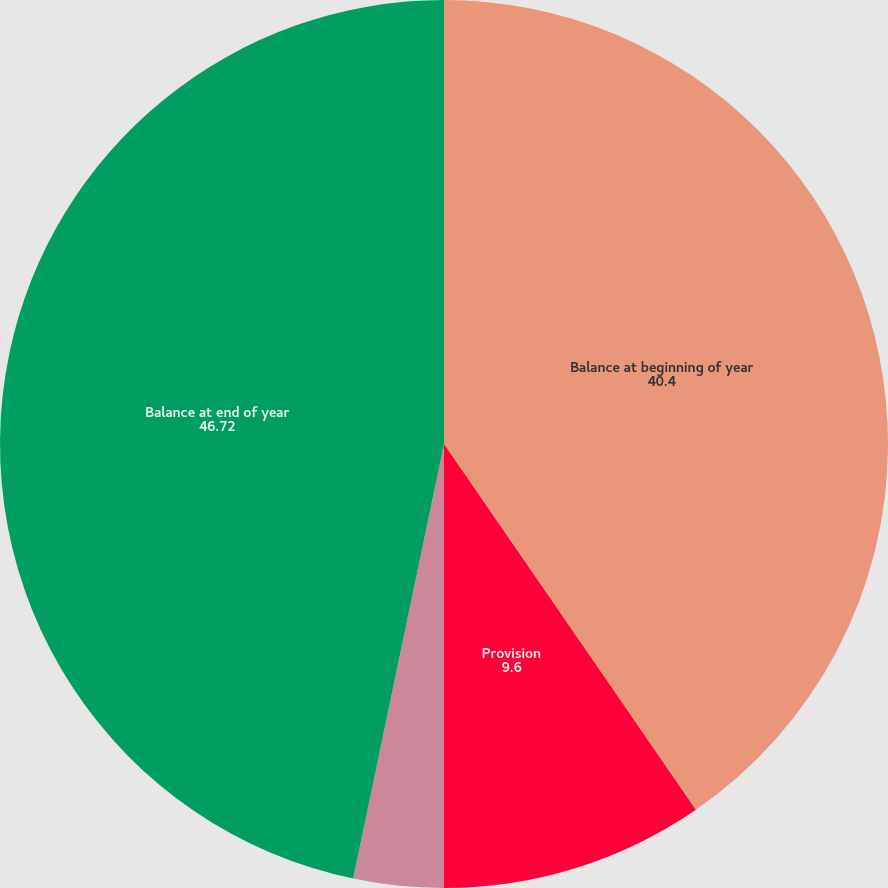Convert chart to OTSL. <chart><loc_0><loc_0><loc_500><loc_500><pie_chart><fcel>Balance at beginning of year<fcel>Provision<fcel>Amounts written off<fcel>Balance at end of year<nl><fcel>40.4%<fcel>9.6%<fcel>3.28%<fcel>46.72%<nl></chart> 